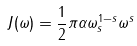<formula> <loc_0><loc_0><loc_500><loc_500>J ( \omega ) = \frac { 1 } { 2 } \pi \alpha \omega _ { s } ^ { 1 - s } \omega ^ { s }</formula> 